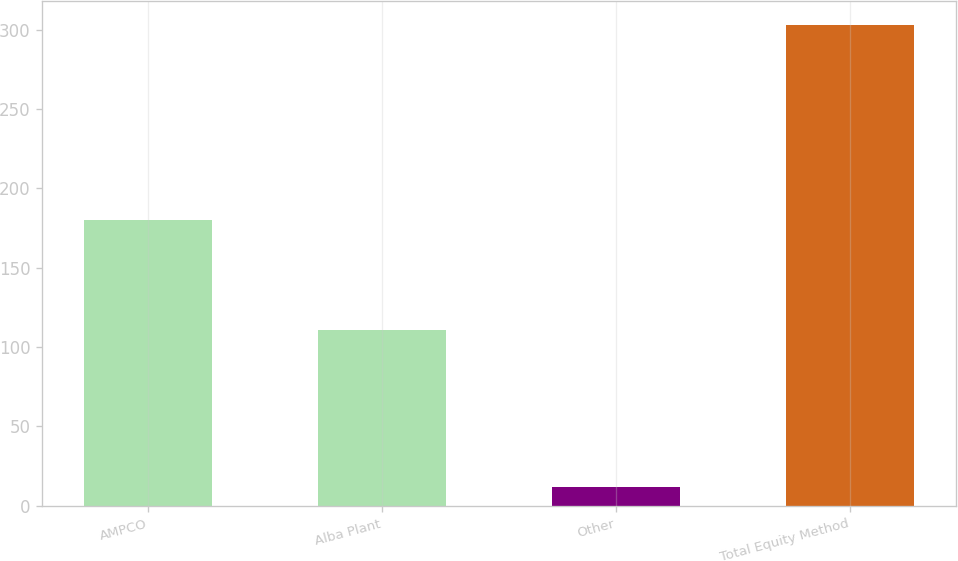Convert chart to OTSL. <chart><loc_0><loc_0><loc_500><loc_500><bar_chart><fcel>AMPCO<fcel>Alba Plant<fcel>Other<fcel>Total Equity Method<nl><fcel>180<fcel>111<fcel>12<fcel>303<nl></chart> 